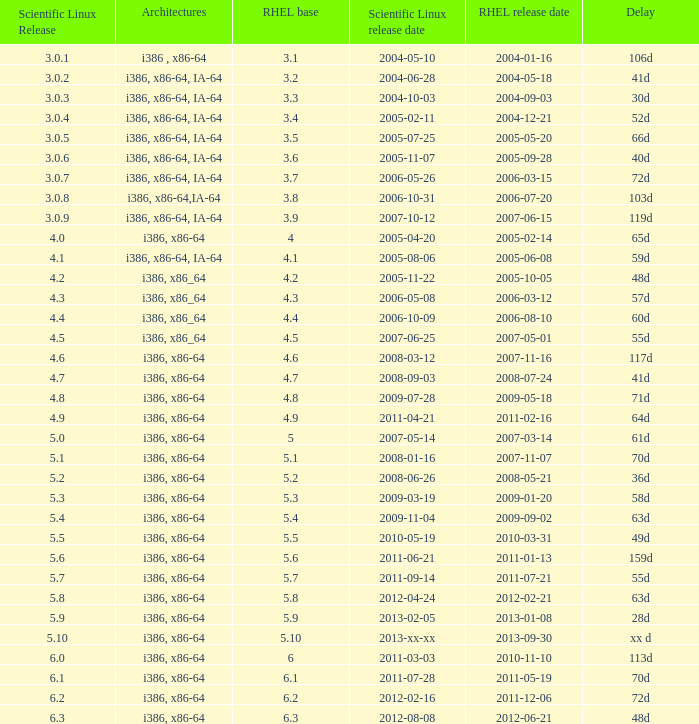When is the rhel release date when scientific linux release is 3.0.4 2004-12-21. 